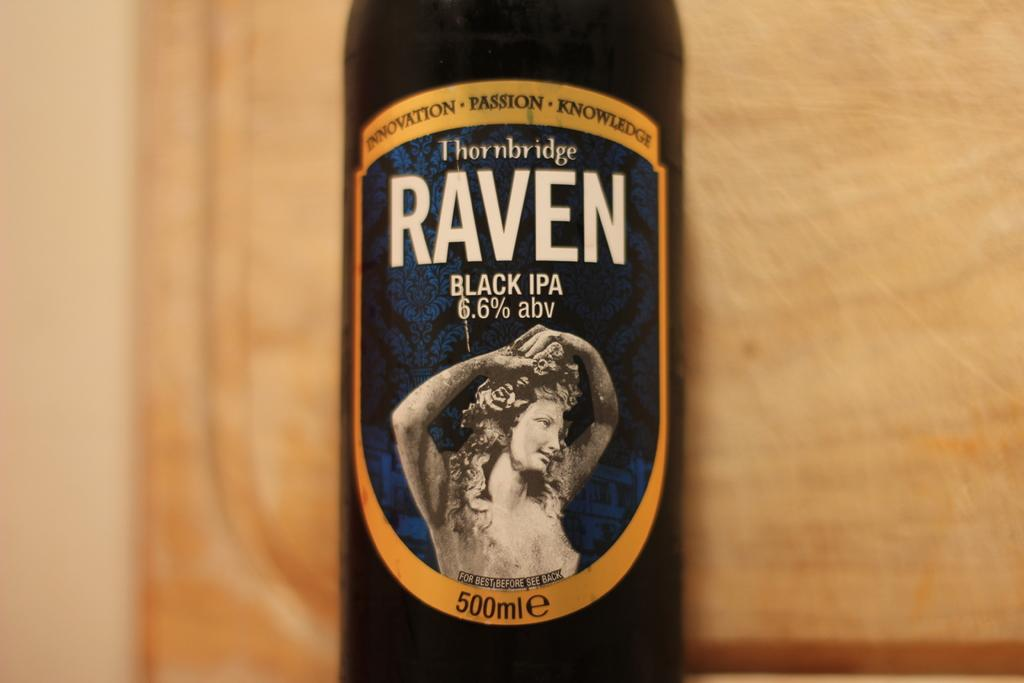<image>
Describe the image concisely. A bottle of Raven that is a black IPA. 